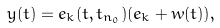<formula> <loc_0><loc_0><loc_500><loc_500>y ( t ) = e _ { k } ( t , t _ { n _ { 0 } } ) ( e _ { k } + w ( t ) ) ,</formula> 